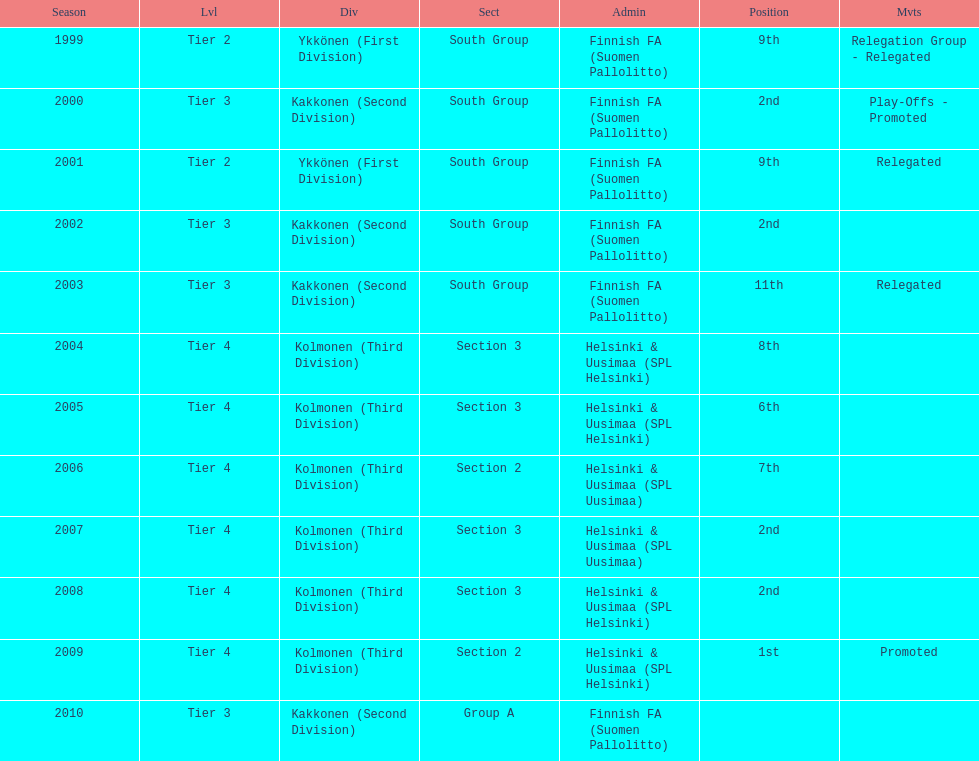What division were they in the most, section 3 or 2? 3. Could you parse the entire table? {'header': ['Season', 'Lvl', 'Div', 'Sect', 'Admin', 'Position', 'Mvts'], 'rows': [['1999', 'Tier 2', 'Ykkönen (First Division)', 'South Group', 'Finnish FA (Suomen Pallolitto)', '9th', 'Relegation Group - Relegated'], ['2000', 'Tier 3', 'Kakkonen (Second Division)', 'South Group', 'Finnish FA (Suomen Pallolitto)', '2nd', 'Play-Offs - Promoted'], ['2001', 'Tier 2', 'Ykkönen (First Division)', 'South Group', 'Finnish FA (Suomen Pallolitto)', '9th', 'Relegated'], ['2002', 'Tier 3', 'Kakkonen (Second Division)', 'South Group', 'Finnish FA (Suomen Pallolitto)', '2nd', ''], ['2003', 'Tier 3', 'Kakkonen (Second Division)', 'South Group', 'Finnish FA (Suomen Pallolitto)', '11th', 'Relegated'], ['2004', 'Tier 4', 'Kolmonen (Third Division)', 'Section 3', 'Helsinki & Uusimaa (SPL Helsinki)', '8th', ''], ['2005', 'Tier 4', 'Kolmonen (Third Division)', 'Section 3', 'Helsinki & Uusimaa (SPL Helsinki)', '6th', ''], ['2006', 'Tier 4', 'Kolmonen (Third Division)', 'Section 2', 'Helsinki & Uusimaa (SPL Uusimaa)', '7th', ''], ['2007', 'Tier 4', 'Kolmonen (Third Division)', 'Section 3', 'Helsinki & Uusimaa (SPL Uusimaa)', '2nd', ''], ['2008', 'Tier 4', 'Kolmonen (Third Division)', 'Section 3', 'Helsinki & Uusimaa (SPL Helsinki)', '2nd', ''], ['2009', 'Tier 4', 'Kolmonen (Third Division)', 'Section 2', 'Helsinki & Uusimaa (SPL Helsinki)', '1st', 'Promoted'], ['2010', 'Tier 3', 'Kakkonen (Second Division)', 'Group A', 'Finnish FA (Suomen Pallolitto)', '', '']]} 